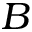<formula> <loc_0><loc_0><loc_500><loc_500>B</formula> 